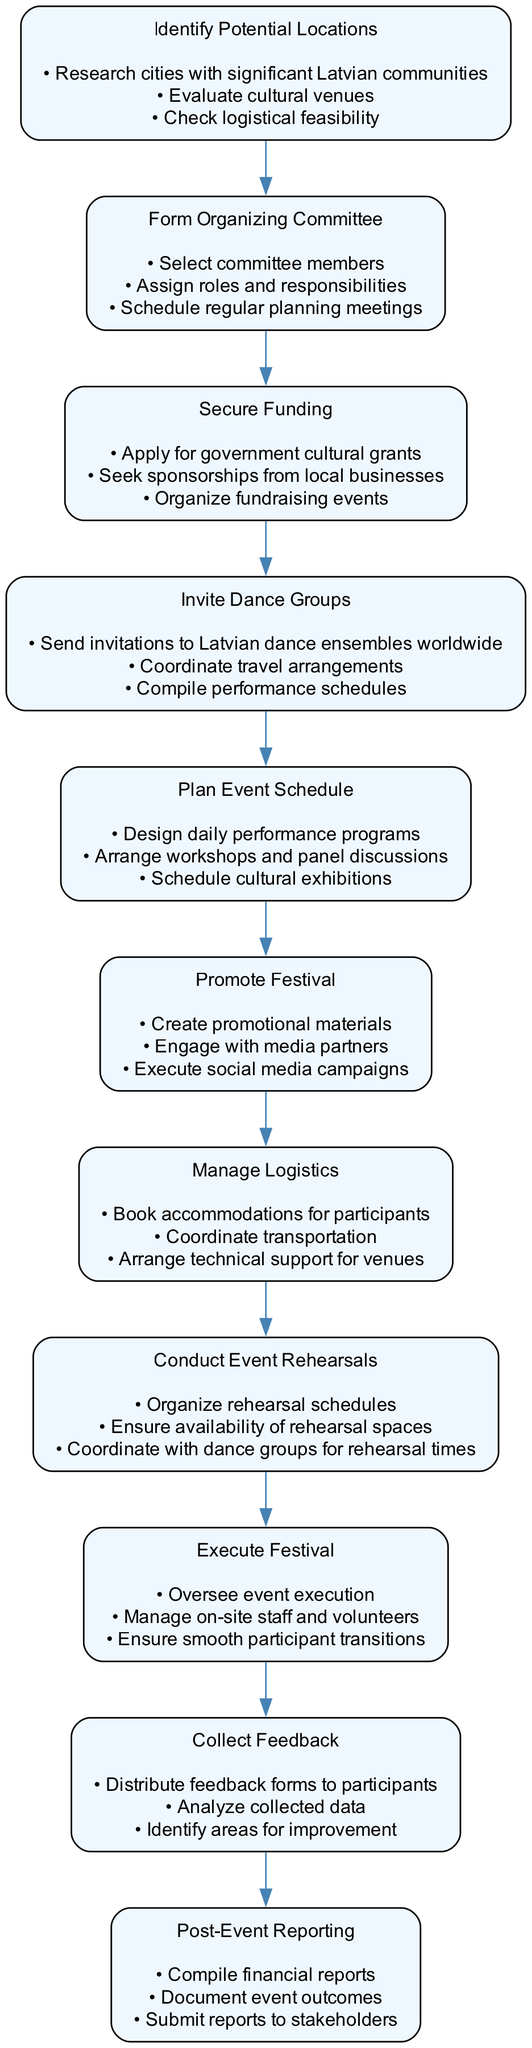What is the first activity in the festival organization? The first activity listed in the diagram is "Identify Potential Locations." This can be determined by analyzing the flow of the activities, starting from the beginning of the diagram.
Answer: Identify Potential Locations How many actions are involved in "Secure Funding"? The "Secure Funding" activity contains three actions: "Apply for government cultural grants," "Seek sponsorships from local businesses," and "Organize fundraising events." I counted the number of actions listed beneath this activity.
Answer: 3 Which activity comes after "Invite Dance Groups"? The next activity after "Invite Dance Groups" is "Plan Event Schedule." This is evident from the sequential flow of activities in the diagram.
Answer: Plan Event Schedule What is the last activity in the festival organization process? The last activity mentioned in the diagram is "Post-Event Reporting." By examining the flow, this is the final step that concludes the entire organization process.
Answer: Post-Event Reporting How many activities are there in total in the diagram? There are a total of eleven activities listed in the diagram. I counted each unique activity from the top to the bottom of the diagram.
Answer: 11 What is the purpose of the "Collect Feedback" activity? The purpose of the "Collect Feedback" activity is to gather insights from participants to assess the event's success and identify areas for improvement. This can be inferred from the actions listed under this activity.
Answer: Gather insights Which activities involve planning? The activities that involve planning are "Form Organizing Committee," "Plan Event Schedule," and "Conduct Event Rehearsals." Each of these activities includes actions that relate to scheduling and organization.
Answer: Form Organizing Committee, Plan Event Schedule, Conduct Event Rehearsals What do you need to manage before executing the festival? Before executing the festival, it is necessary to "Manage Logistics." This activity involves organizing accommodations, transportation, and technical support, which must be handled prior to the festival.
Answer: Manage Logistics How does "Promote Festival" relate to "Invite Dance Groups"? "Promote Festival" follows "Invite Dance Groups" in the sequence. The relationship indicates that after dance groups are invited, the next step is to promote the festival, highlighting the interconnectedness of these activities.
Answer: Promotion follows invitations 